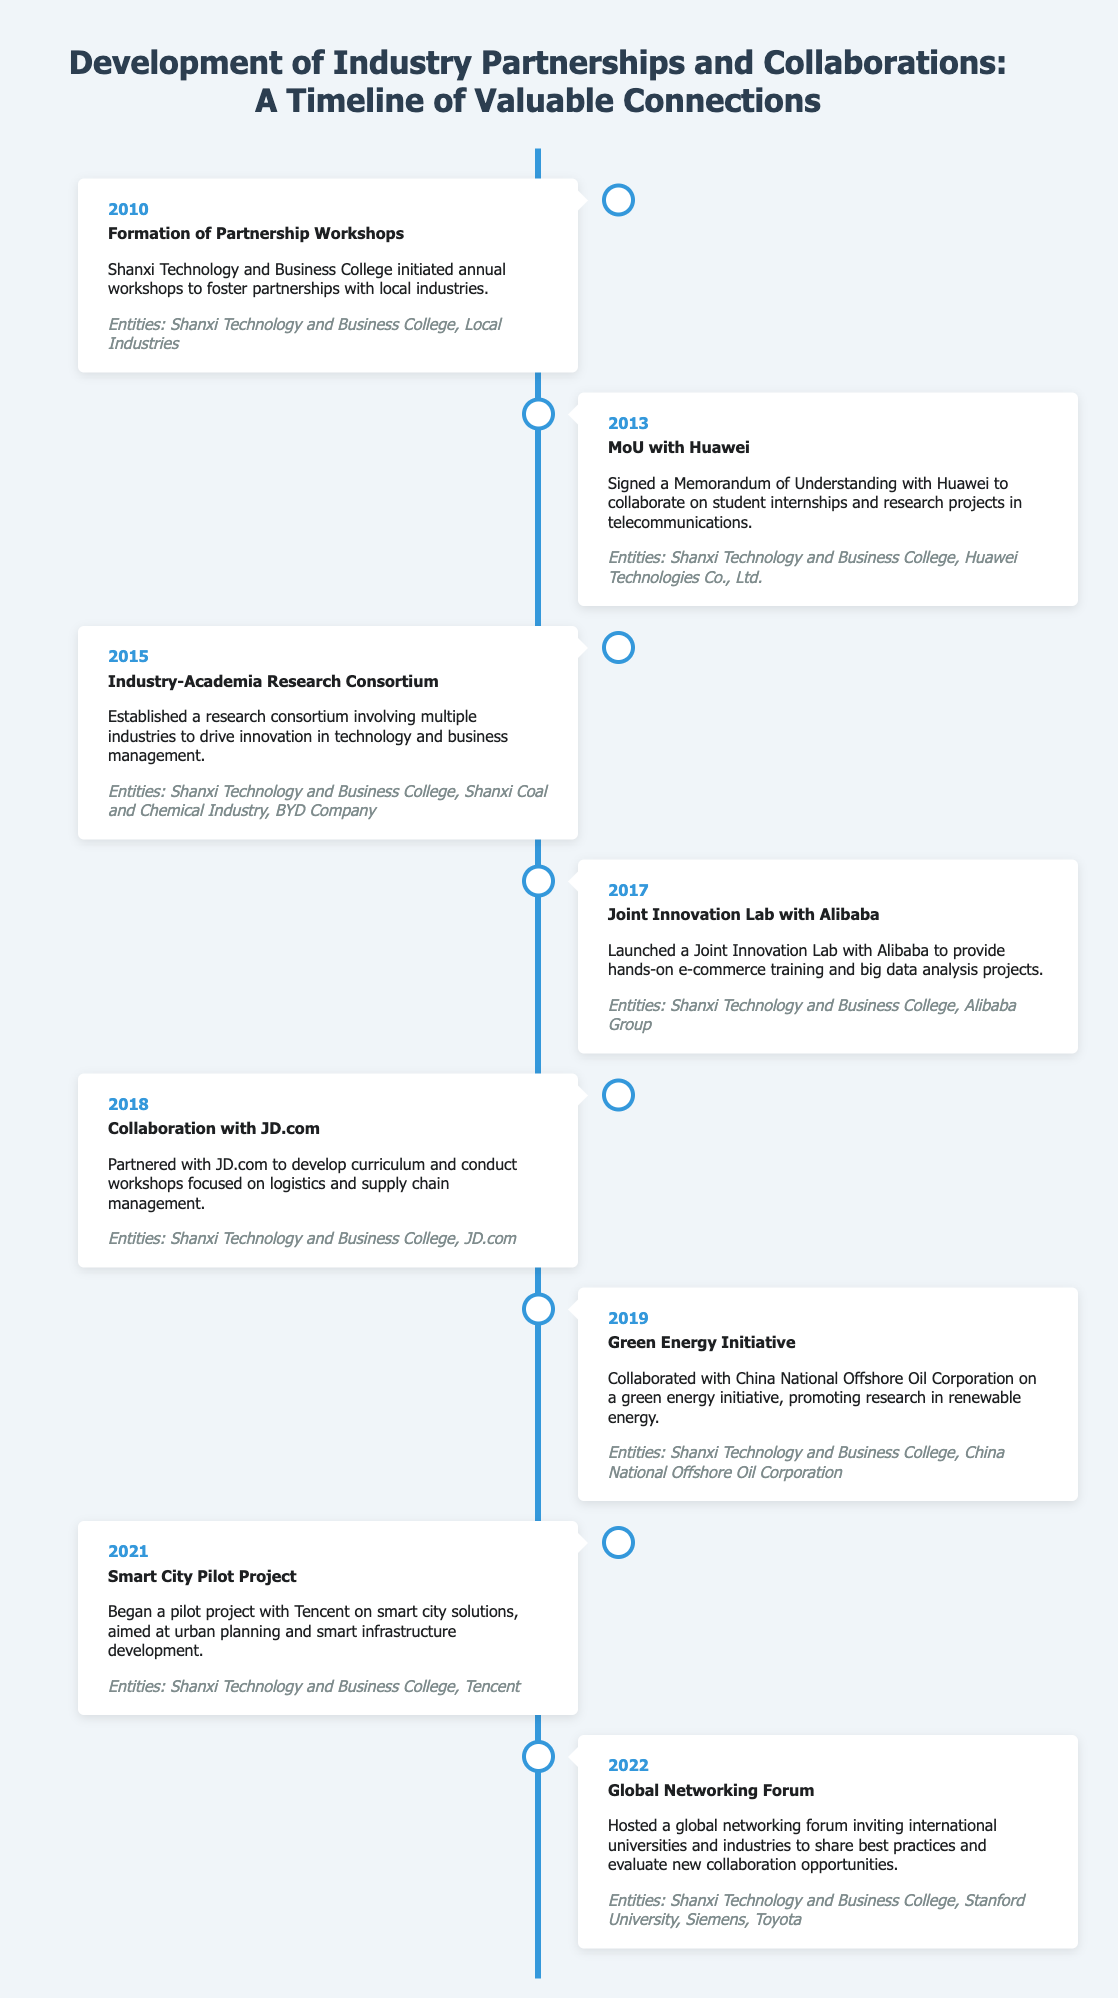What year was the formation of Partnership Workshops? The year specified in the document for the formation of Partnership Workshops is 2010.
Answer: 2010 What entity signed a Memorandum of Understanding with Shanxi Technology and Business College in 2013? The document indicates that Huawei Technologies Co., Ltd. signed a Memorandum of Understanding with Shanxi Technology and Business College.
Answer: Huawei Technologies Co., Ltd How many years separated the Industry-Academia Research Consortium from the MoU with Huawei? The MoU with Huawei was signed in 2013 and the Industry-Academia Research Consortium was established in 2015, resulting in a two-year difference.
Answer: 2 Which company collaborated with Shanxi Technology and Business College for a Smart City Pilot Project in 2021? According to the document, Tencent collaborated for the Smart City Pilot Project in 2021.
Answer: Tencent What major theme was addressed by the Green Energy Initiative in 2019? The Green Energy Initiative focused on promoting research in renewable energy as mentioned in the document.
Answer: Renewable energy What is the significance of the Global Networking Forum held in 2022? The Global Networking Forum aimed to invite international universities and industries to share best practices and evaluate new collaboration opportunities.
Answer: Evaluate new collaboration opportunities What type of collaboration was established with Alibaba in 2017? The collaboration with Alibaba was a Joint Innovation Lab focusing on e-commerce training and big data analysis projects.
Answer: Joint Innovation Lab Which two entities were involved in the curriculum development with JD.com in 2018? The entities involved in the collaboration with JD.com for curriculum development were Shanxi Technology and Business College and JD.com.
Answer: Shanxi Technology and Business College, JD.com 